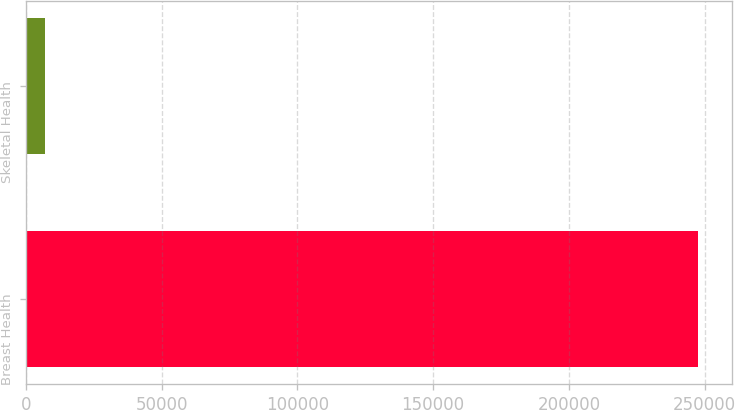<chart> <loc_0><loc_0><loc_500><loc_500><bar_chart><fcel>Breast Health<fcel>Skeletal Health<nl><fcel>247652<fcel>6909<nl></chart> 